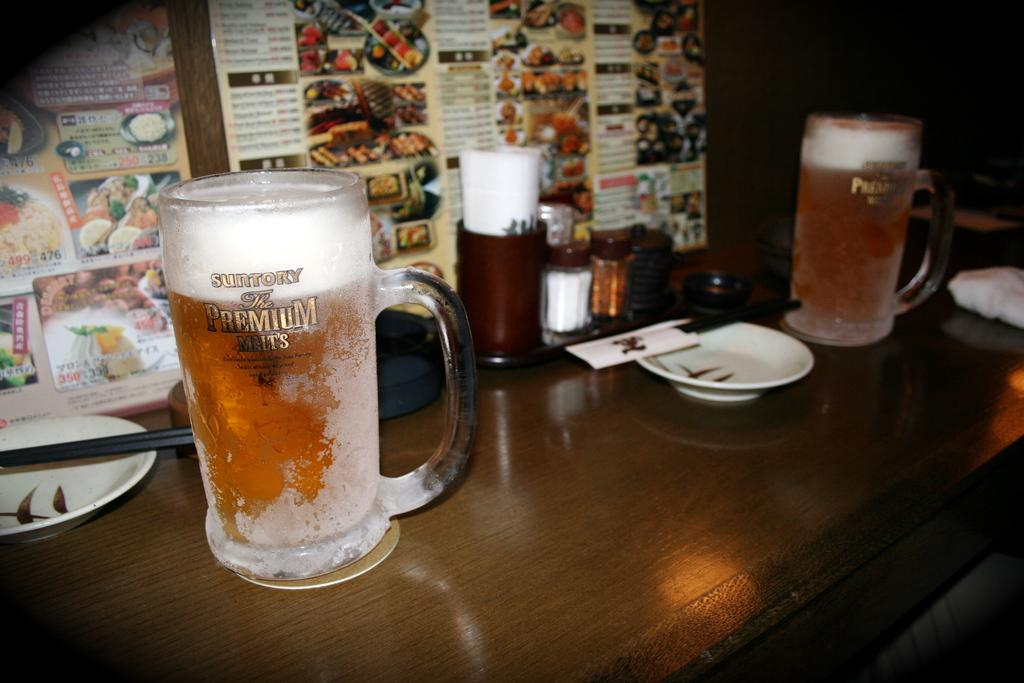<image>
Write a terse but informative summary of the picture. a beer glass that says The Premium Malts on it 